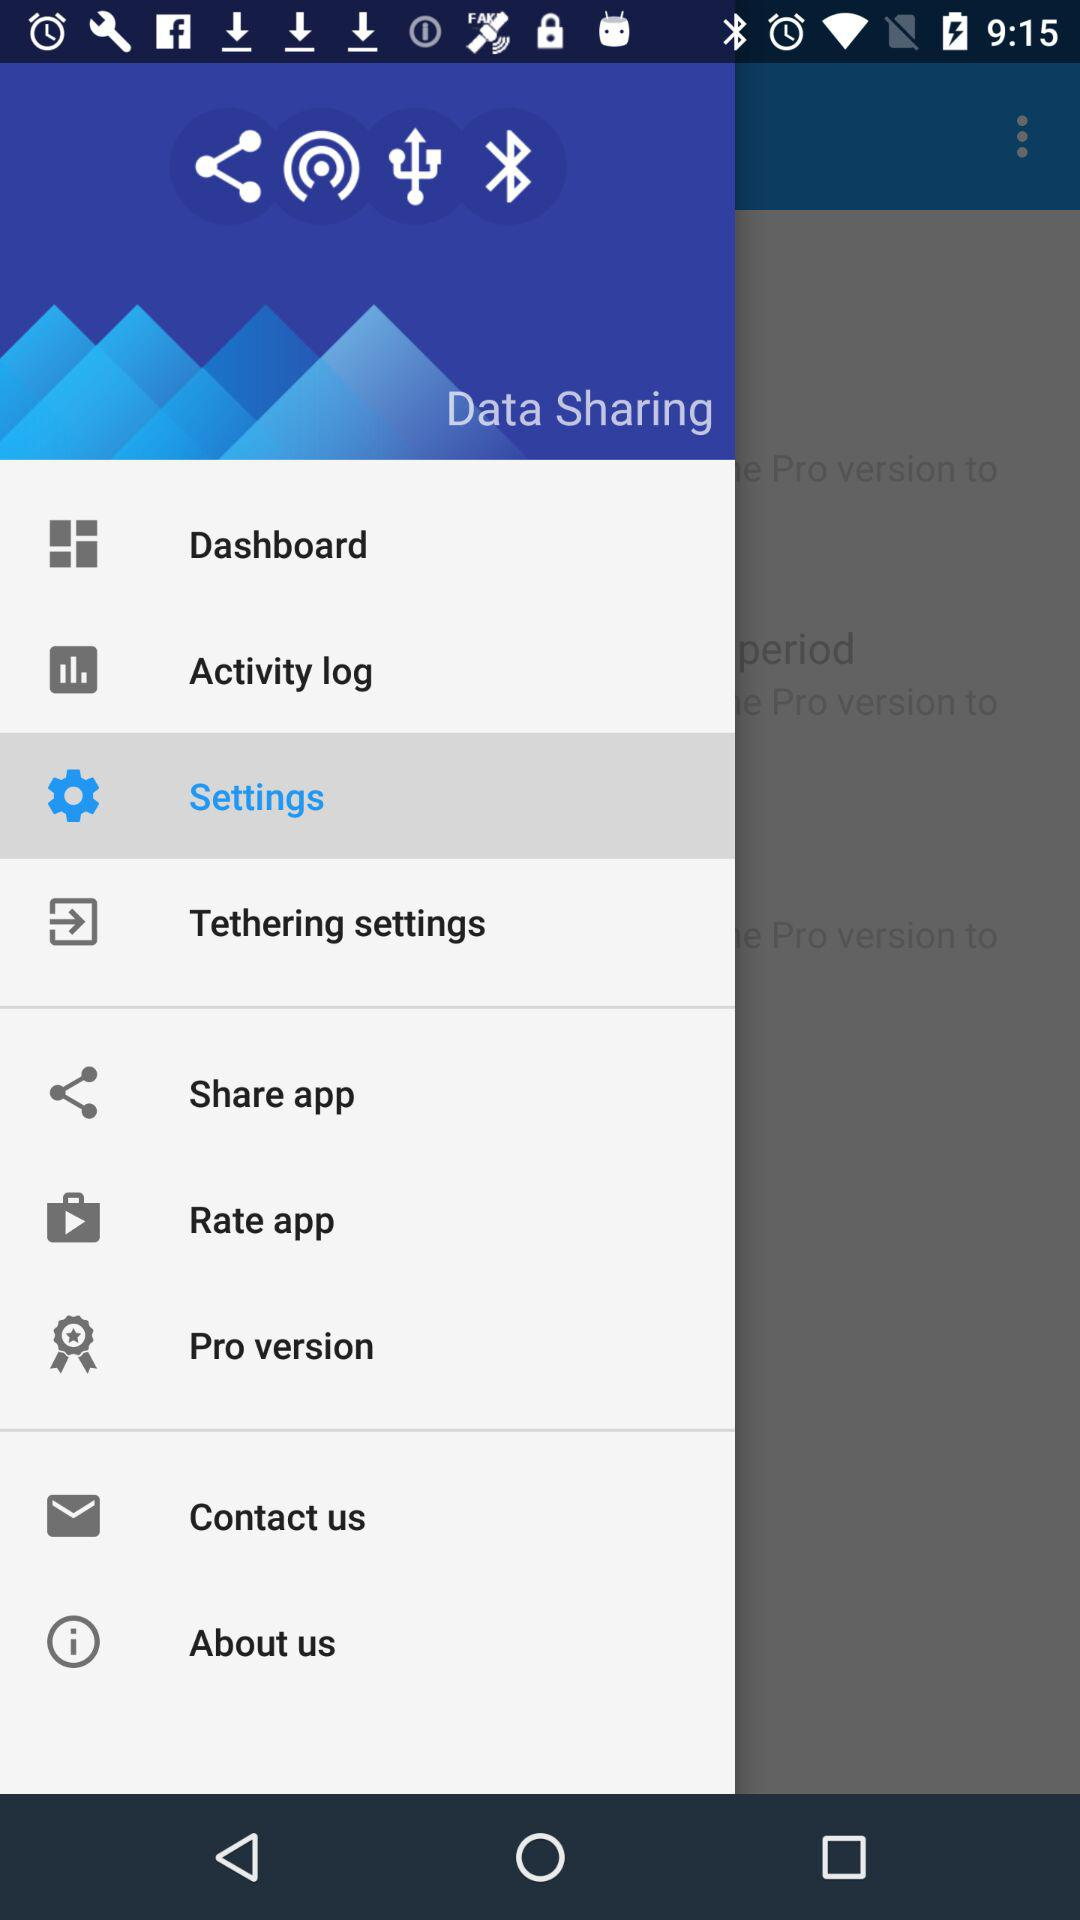Which item has been selected? The item that has been selected is "Settings". 